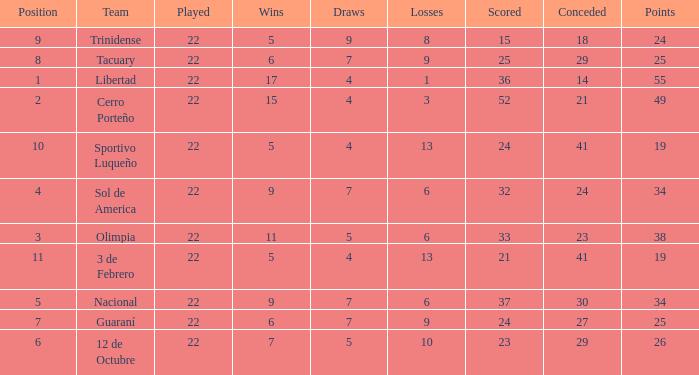What was the number of losses when the scored value was 25? 9.0. 